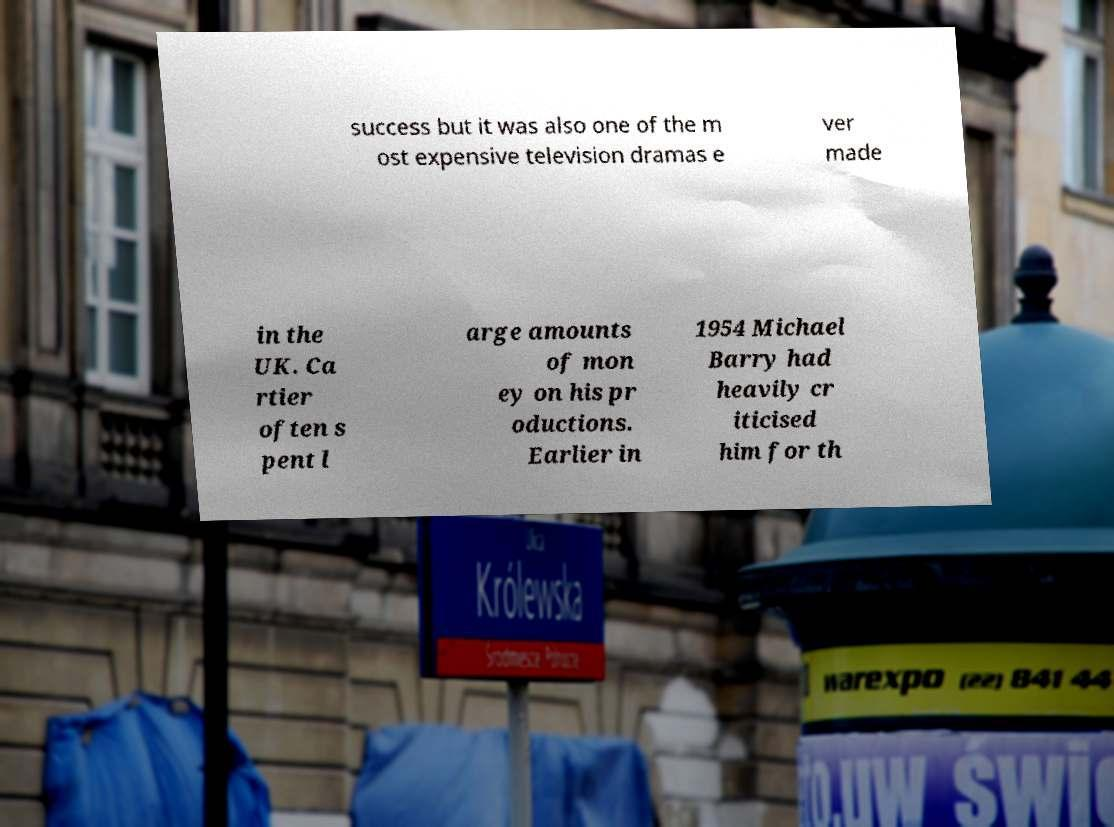Can you read and provide the text displayed in the image?This photo seems to have some interesting text. Can you extract and type it out for me? success but it was also one of the m ost expensive television dramas e ver made in the UK. Ca rtier often s pent l arge amounts of mon ey on his pr oductions. Earlier in 1954 Michael Barry had heavily cr iticised him for th 